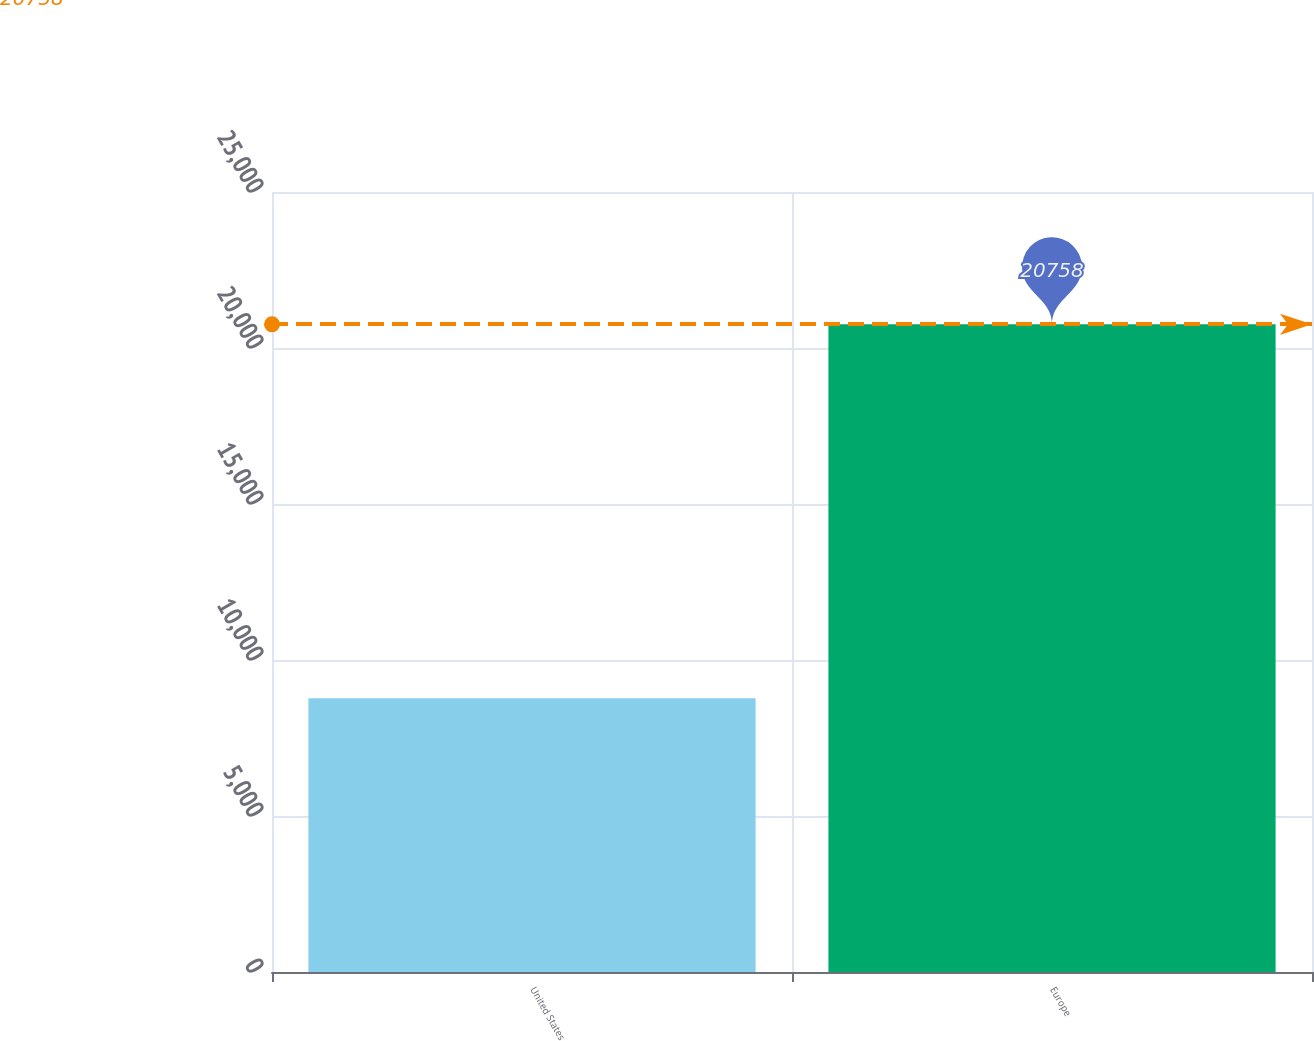Convert chart. <chart><loc_0><loc_0><loc_500><loc_500><bar_chart><fcel>United States<fcel>Europe<nl><fcel>8772<fcel>20758<nl></chart> 